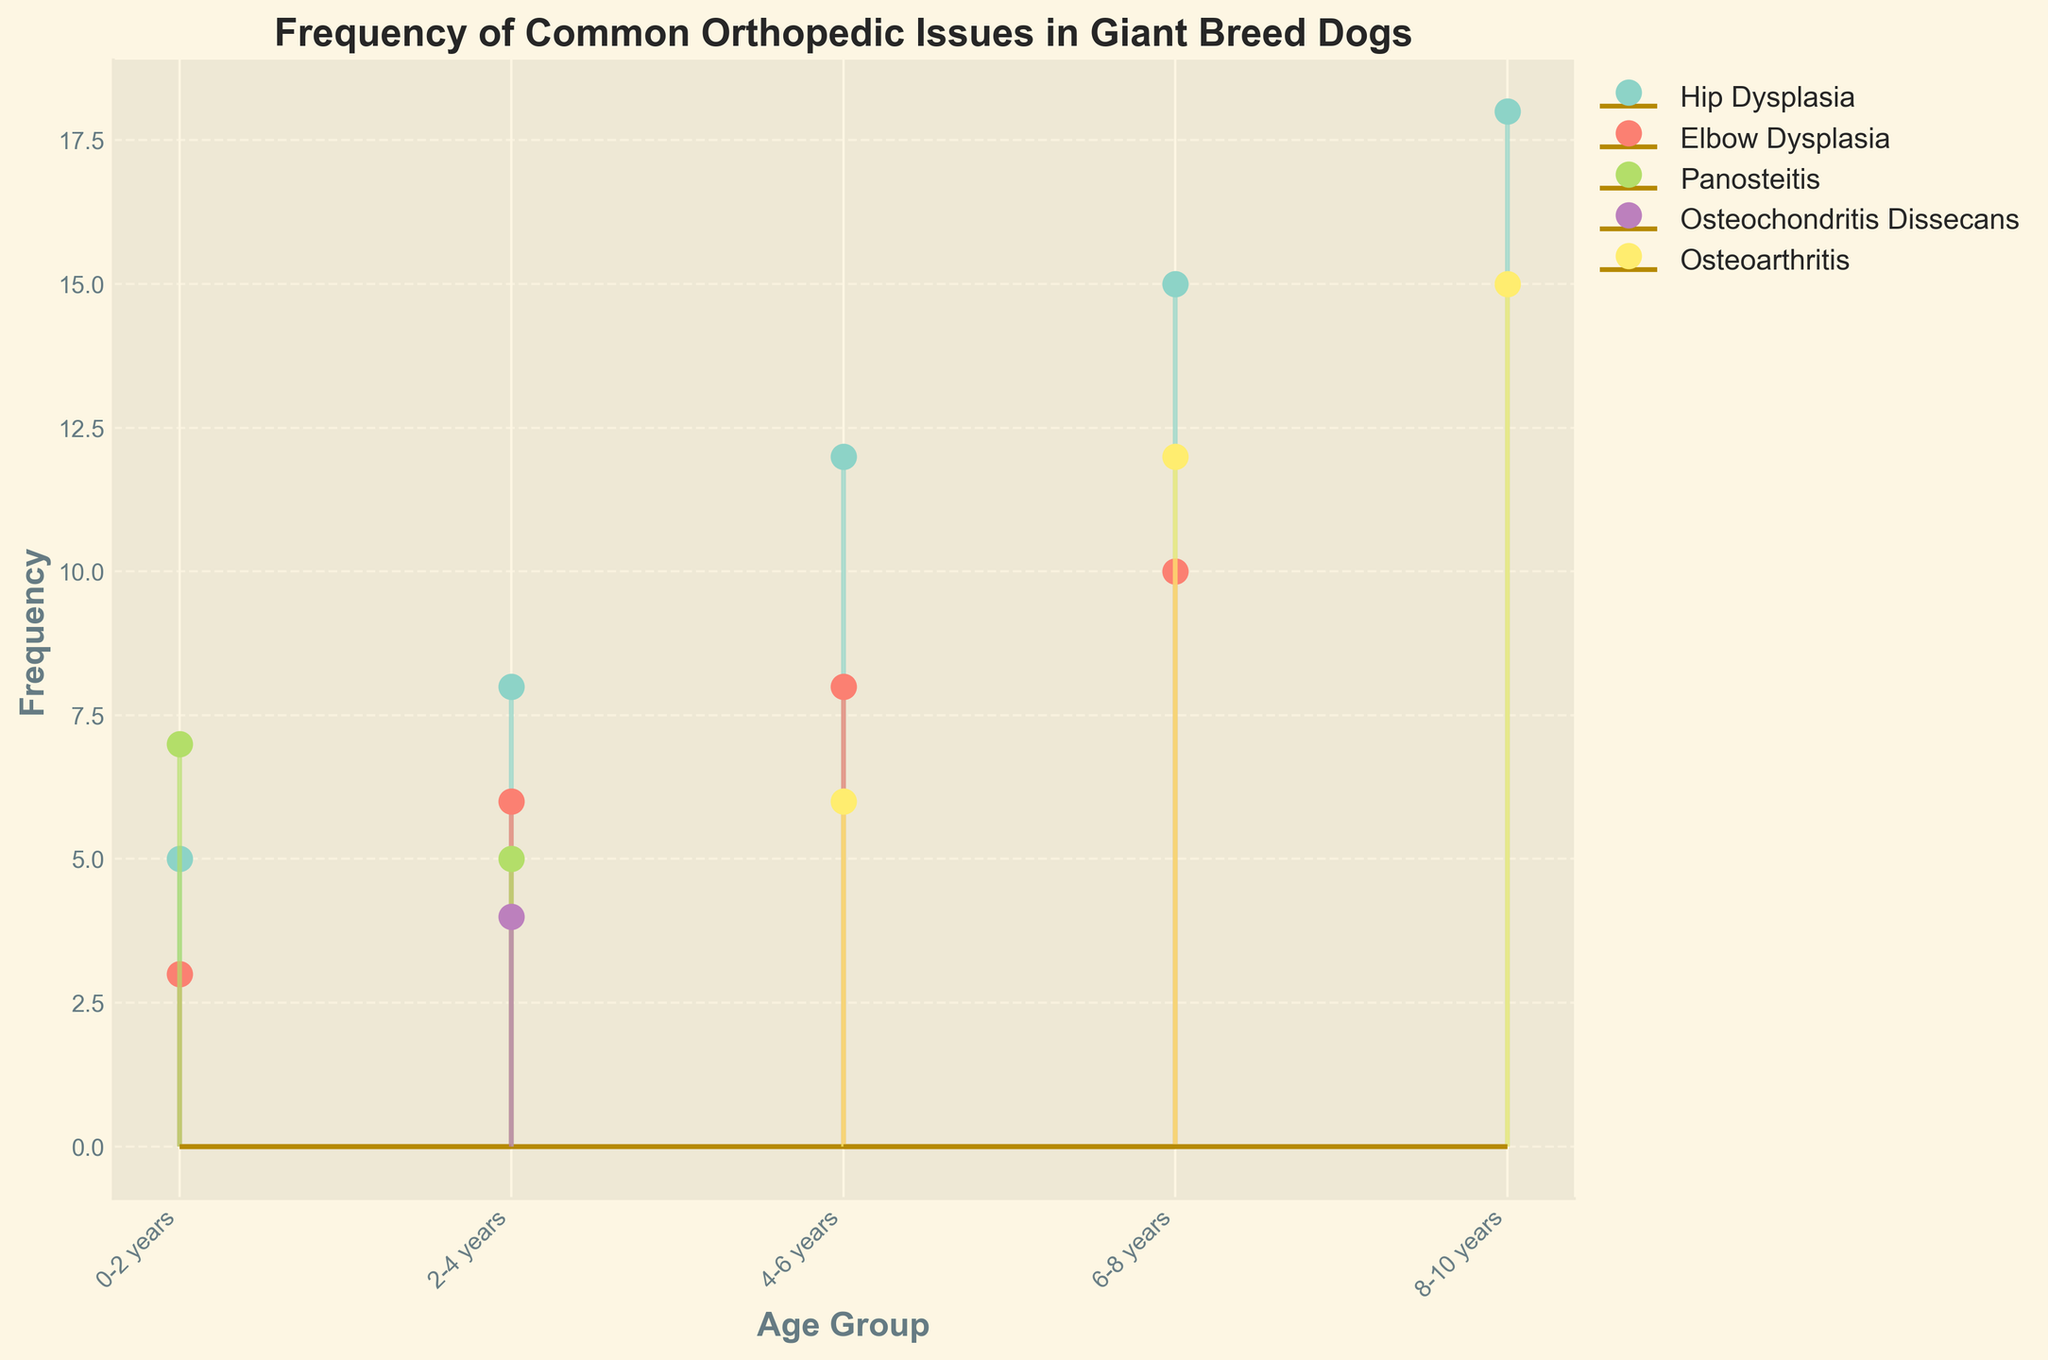What is the title of the plot? The title of the plot is typically found at the top of the figure in larger, bold text. In this case, it specifies the main focus of the plot.
Answer: Frequency of Common Orthopedic Issues in Giant Breed Dogs How many age groups are included in the plot? To determine the number of age groups, look at the x-axis labels. Each unique label represents a different age group.
Answer: 5 Which orthopedic issue has the highest frequency in the 6-8 years age group? Identify the data points corresponding to the 6-8 years age group. Then, compare the heights of the stems to find the maximum value.
Answer: Hip Dysplasia What is the combined frequency of Panosteitis across all age groups? Add the frequencies of Panosteitis from each age group: 7 (0-2 years) + 5 (2-4 years).
Answer: 12 Which condition first appears in the 2-4 years age group and what is its frequency? Look at the stems for the 2-4 years group and note any condition that is not present in earlier age groups.
Answer: Osteochondritis Dissecans, 4 Is the frequency of osteoarthritis higher in the 4-6 years or 8-10 years age group? Compare the stem heights of osteoarthritis between the 4-6 years and 8-10 years age groups.
Answer: 8-10 years Which condition shows a consistent increase in frequency with age? Observe the trend of frequency for each condition across successive age groups and identify the one with a consistent upward trend.
Answer: Hip Dysplasia What is the frequency difference of Hip Dysplasia between the 2-4 years and 8-10 years age groups? Subtract the frequency of Hip Dysplasia in the 2-4 years age group (8) from that in the 8-10 years age group (18).
Answer: 10 Which two age groups have the highest total frequency of orthopedic issues? Sum the frequencies of all conditions in each age group and compare the sums to identify the two highest.
Answer: 6-8 years and 8-10 years 